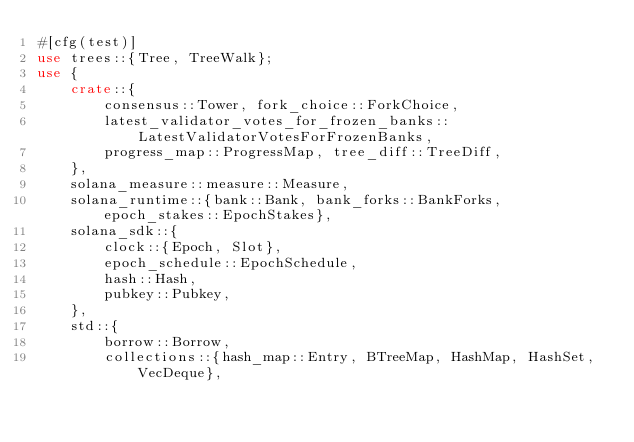<code> <loc_0><loc_0><loc_500><loc_500><_Rust_>#[cfg(test)]
use trees::{Tree, TreeWalk};
use {
    crate::{
        consensus::Tower, fork_choice::ForkChoice,
        latest_validator_votes_for_frozen_banks::LatestValidatorVotesForFrozenBanks,
        progress_map::ProgressMap, tree_diff::TreeDiff,
    },
    solana_measure::measure::Measure,
    solana_runtime::{bank::Bank, bank_forks::BankForks, epoch_stakes::EpochStakes},
    solana_sdk::{
        clock::{Epoch, Slot},
        epoch_schedule::EpochSchedule,
        hash::Hash,
        pubkey::Pubkey,
    },
    std::{
        borrow::Borrow,
        collections::{hash_map::Entry, BTreeMap, HashMap, HashSet, VecDeque},</code> 